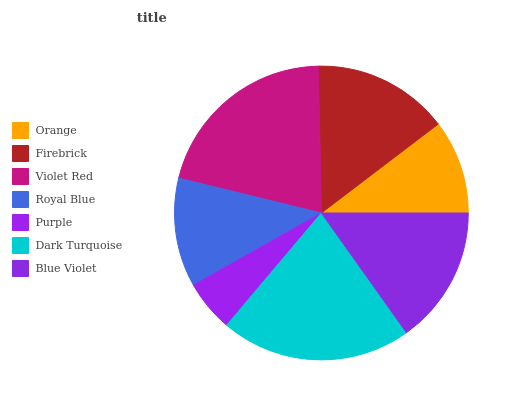Is Purple the minimum?
Answer yes or no. Yes. Is Dark Turquoise the maximum?
Answer yes or no. Yes. Is Firebrick the minimum?
Answer yes or no. No. Is Firebrick the maximum?
Answer yes or no. No. Is Firebrick greater than Orange?
Answer yes or no. Yes. Is Orange less than Firebrick?
Answer yes or no. Yes. Is Orange greater than Firebrick?
Answer yes or no. No. Is Firebrick less than Orange?
Answer yes or no. No. Is Firebrick the high median?
Answer yes or no. Yes. Is Firebrick the low median?
Answer yes or no. Yes. Is Purple the high median?
Answer yes or no. No. Is Orange the low median?
Answer yes or no. No. 